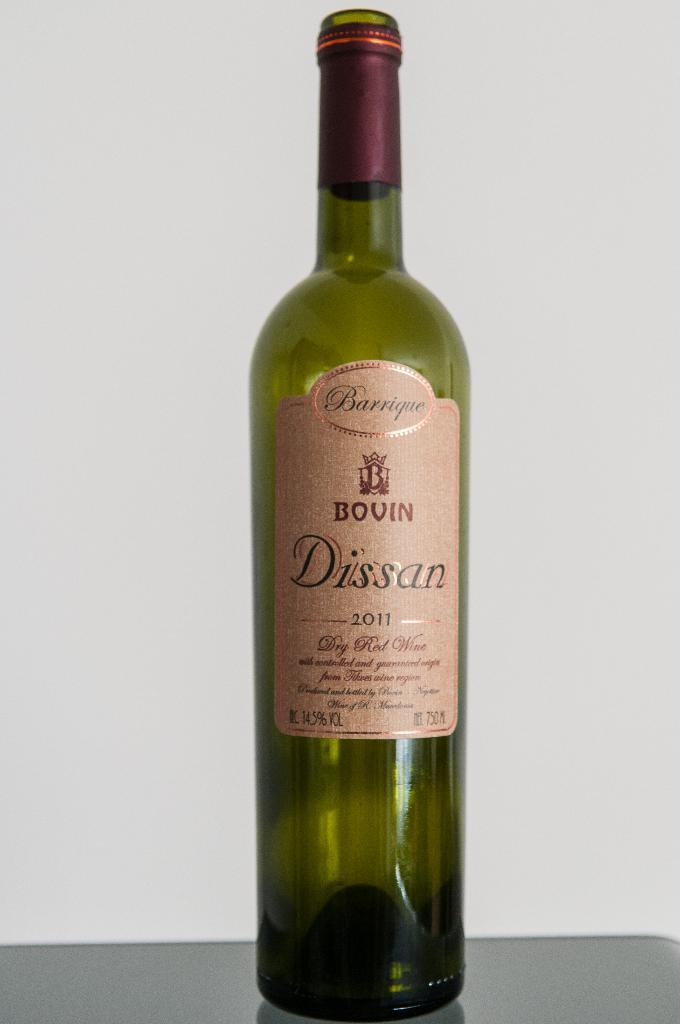Provide a one-sentence caption for the provided image. Long wine bottle with a label which says it is from 2011. 